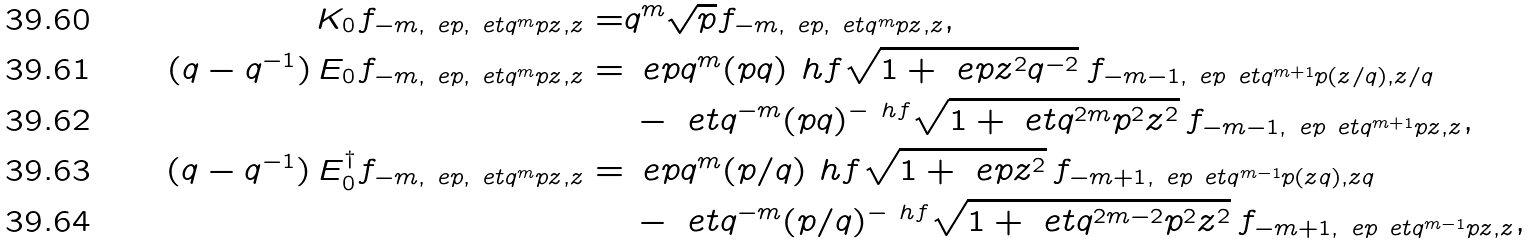Convert formula to latex. <formula><loc_0><loc_0><loc_500><loc_500>K _ { 0 } f _ { - m , \ e p , \ e t q ^ { m } p z , z } = & q ^ { m } \sqrt { p } f _ { - m , \ e p , \ e t q ^ { m } p z , z } , \\ ( q - q ^ { - 1 } ) \, E _ { 0 } f _ { - m , \ e p , \ e t q ^ { m } p z , z } = & \, \ e p q ^ { m } ( p q ) ^ { \ } h f \sqrt { 1 + \ e p z ^ { 2 } q ^ { - 2 } } \, f _ { - m - 1 , \ e p \ e t q ^ { m + 1 } p ( z / q ) , z / q } \\ & \, - \ e t q ^ { - m } ( p q ) ^ { - \ h f } \sqrt { 1 + \ e t q ^ { 2 m } p ^ { 2 } z ^ { 2 } } \, f _ { - m - 1 , \ e p \ e t q ^ { m + 1 } p z , z } , \\ ( q - q ^ { - 1 } ) \, E _ { 0 } ^ { \dag } f _ { - m , \ e p , \ e t q ^ { m } p z , z } = & \, \ e p q ^ { m } ( p / q ) ^ { \ } h f \sqrt { 1 + \ e p z ^ { 2 } } \, f _ { - m + 1 , \ e p \ e t q ^ { m - 1 } p ( z q ) , z q } \\ & \, - \ e t q ^ { - m } ( p / q ) ^ { - \ h f } \sqrt { 1 + \ e t q ^ { 2 m - 2 } p ^ { 2 } z ^ { 2 } } \, f _ { - m + 1 , \ e p \ e t q ^ { m - 1 } p z , z } ,</formula> 